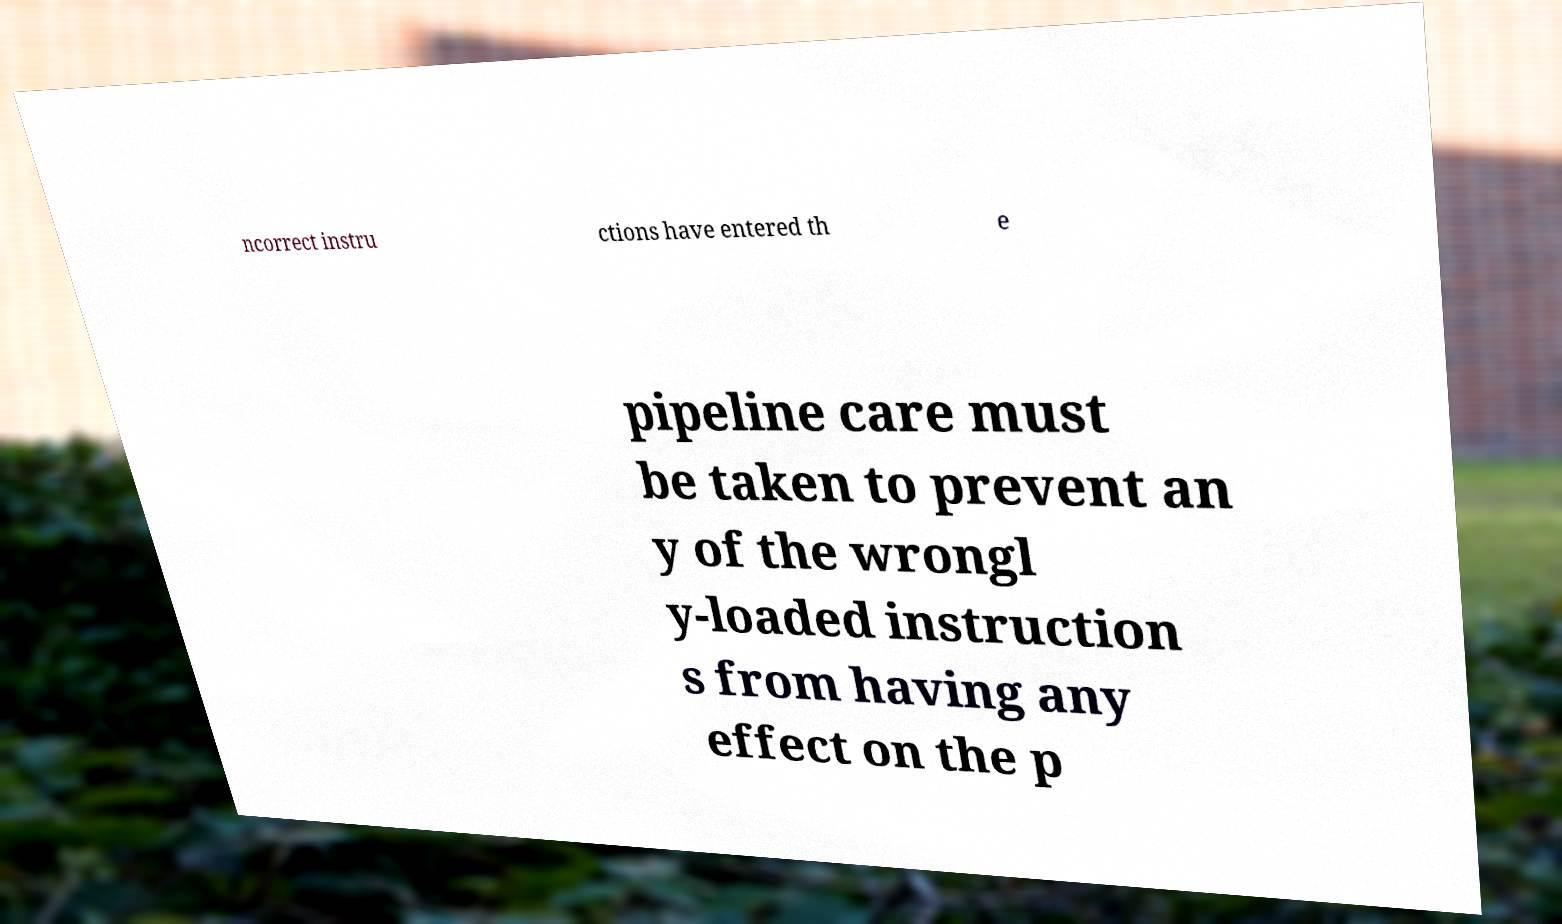Please identify and transcribe the text found in this image. ncorrect instru ctions have entered th e pipeline care must be taken to prevent an y of the wrongl y-loaded instruction s from having any effect on the p 